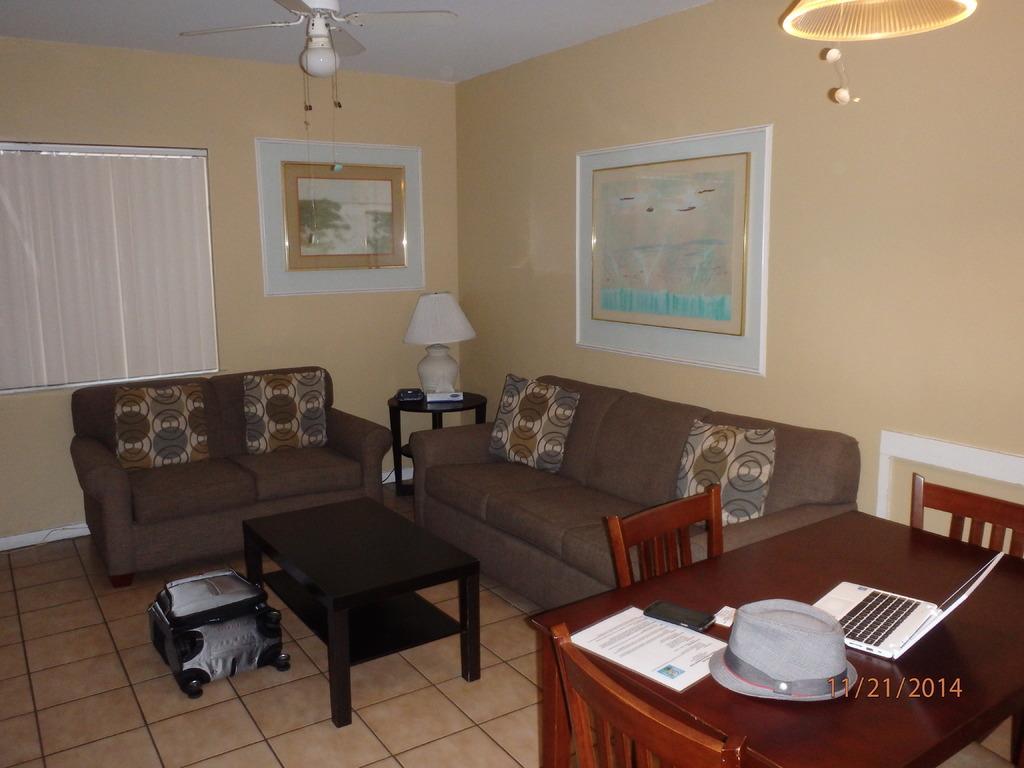Can you describe this image briefly? In this image I see a sofa set, a table, a lamp on the stool and a dining table surrounded with chairs and a laptop, hat, papers and a mobile phone on the dining table and In the background I see the wall and 2 photo frames on it. 